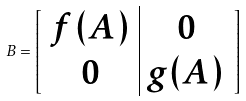<formula> <loc_0><loc_0><loc_500><loc_500>B = \left [ \begin{array} [ c ] { c | c } f ( A ) & 0 \\ 0 & g ( A ) \end{array} \right ]</formula> 